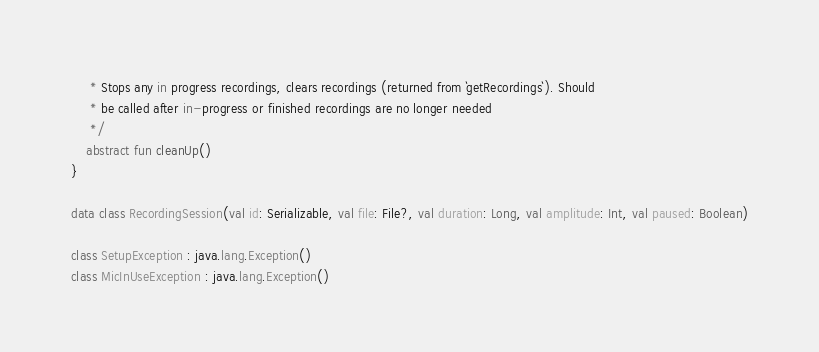<code> <loc_0><loc_0><loc_500><loc_500><_Kotlin_>     * Stops any in progress recordings, clears recordings (returned from `getRecordings`). Should
     * be called after in-progress or finished recordings are no longer needed
     */
    abstract fun cleanUp()
}

data class RecordingSession(val id: Serializable, val file: File?, val duration: Long, val amplitude: Int, val paused: Boolean)

class SetupException : java.lang.Exception()
class MicInUseException : java.lang.Exception()
</code> 